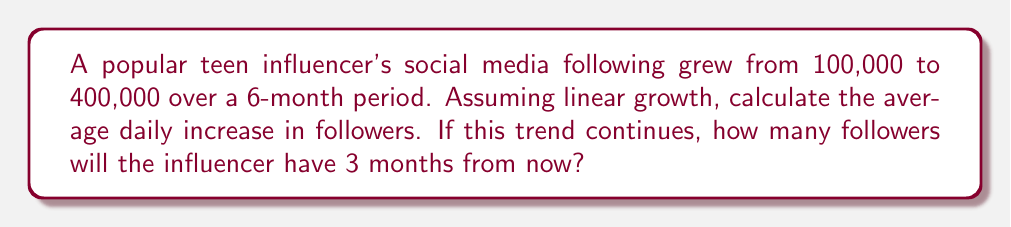Show me your answer to this math problem. 1. Calculate the total increase in followers:
   $400,000 - 100,000 = 300,000$ followers

2. Convert 6 months to days:
   $6 \text{ months} \times 30 \text{ days/month} = 180 \text{ days}$

3. Calculate the average daily increase:
   $$\text{Daily increase} = \frac{\text{Total increase}}{\text{Number of days}} = \frac{300,000}{180} = 1,666.67 \text{ followers/day}$$

4. Calculate the number of followers after 3 more months:
   a. Convert 3 months to days:
      $3 \text{ months} \times 30 \text{ days/month} = 90 \text{ days}$
   
   b. Calculate the increase over 90 days:
      $1,666.67 \text{ followers/day} \times 90 \text{ days} = 150,000 \text{ followers}$
   
   c. Add this to the current number of followers:
      $400,000 + 150,000 = 550,000 \text{ followers}$
Answer: 1,666.67 followers/day; 550,000 followers 